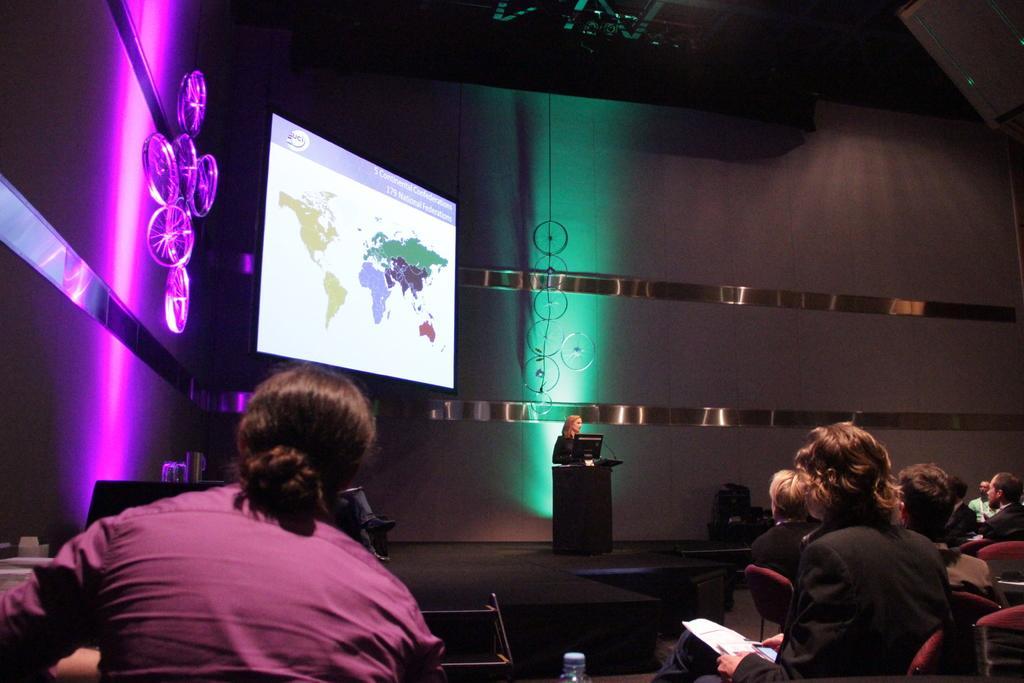Could you give a brief overview of what you see in this image? At the bottom I can see a group of people are sitting on the chairs and one person is standing on the stage in front of a table. In the background I can see a screen, metal rods, focus lights and a rooftop. This image is taken may be in a hall. 